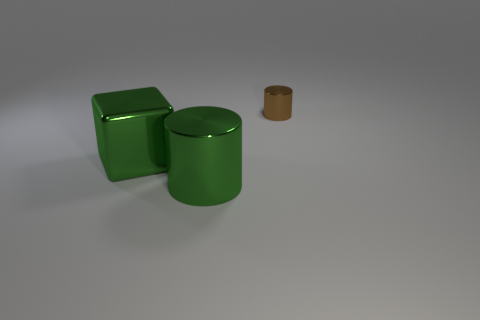Is there any other thing that has the same size as the brown metal thing?
Give a very brief answer. No. How many other objects are there of the same color as the tiny shiny cylinder?
Give a very brief answer. 0. What is the material of the cylinder that is left of the metallic cylinder that is on the right side of the cylinder that is on the left side of the tiny object?
Offer a terse response. Metal. How many cylinders are either brown metal objects or green metal objects?
Your response must be concise. 2. What number of green cylinders are left of the green thing that is to the left of the metal cylinder to the left of the tiny object?
Provide a short and direct response. 0. Does the cylinder that is in front of the small brown cylinder have the same material as the small brown cylinder behind the shiny cube?
Your answer should be very brief. Yes. What number of objects are either shiny cylinders in front of the tiny metallic cylinder or things behind the large green metallic cylinder?
Offer a terse response. 3. Is there anything else that is the same shape as the small metallic thing?
Provide a short and direct response. Yes. What number of tiny cyan matte balls are there?
Your answer should be very brief. 0. Is there a brown rubber cylinder that has the same size as the green block?
Keep it short and to the point. No. 